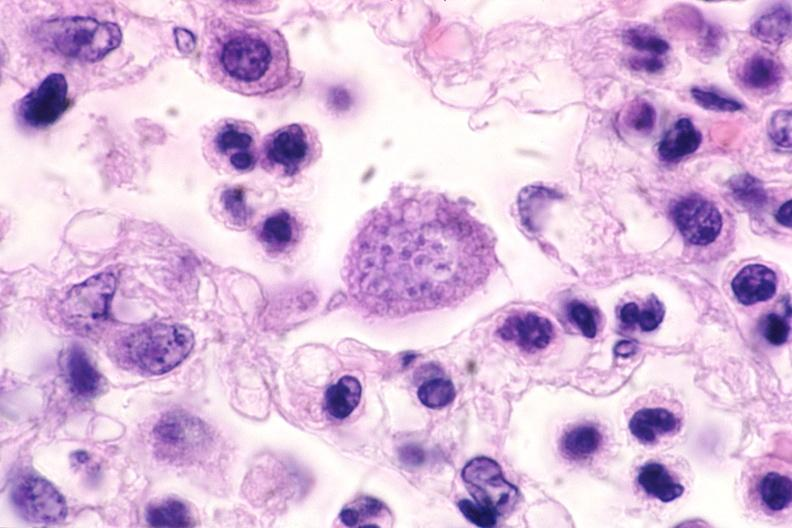where is this?
Answer the question using a single word or phrase. Nervous 